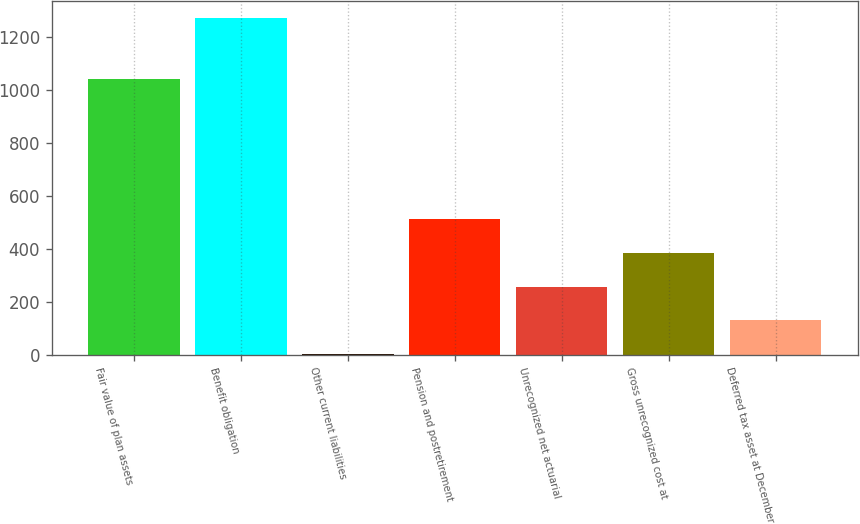<chart> <loc_0><loc_0><loc_500><loc_500><bar_chart><fcel>Fair value of plan assets<fcel>Benefit obligation<fcel>Other current liabilities<fcel>Pension and postretirement<fcel>Unrecognized net actuarial<fcel>Gross unrecognized cost at<fcel>Deferred tax asset at December<nl><fcel>1042<fcel>1274<fcel>3<fcel>511.4<fcel>257.2<fcel>384.3<fcel>130.1<nl></chart> 